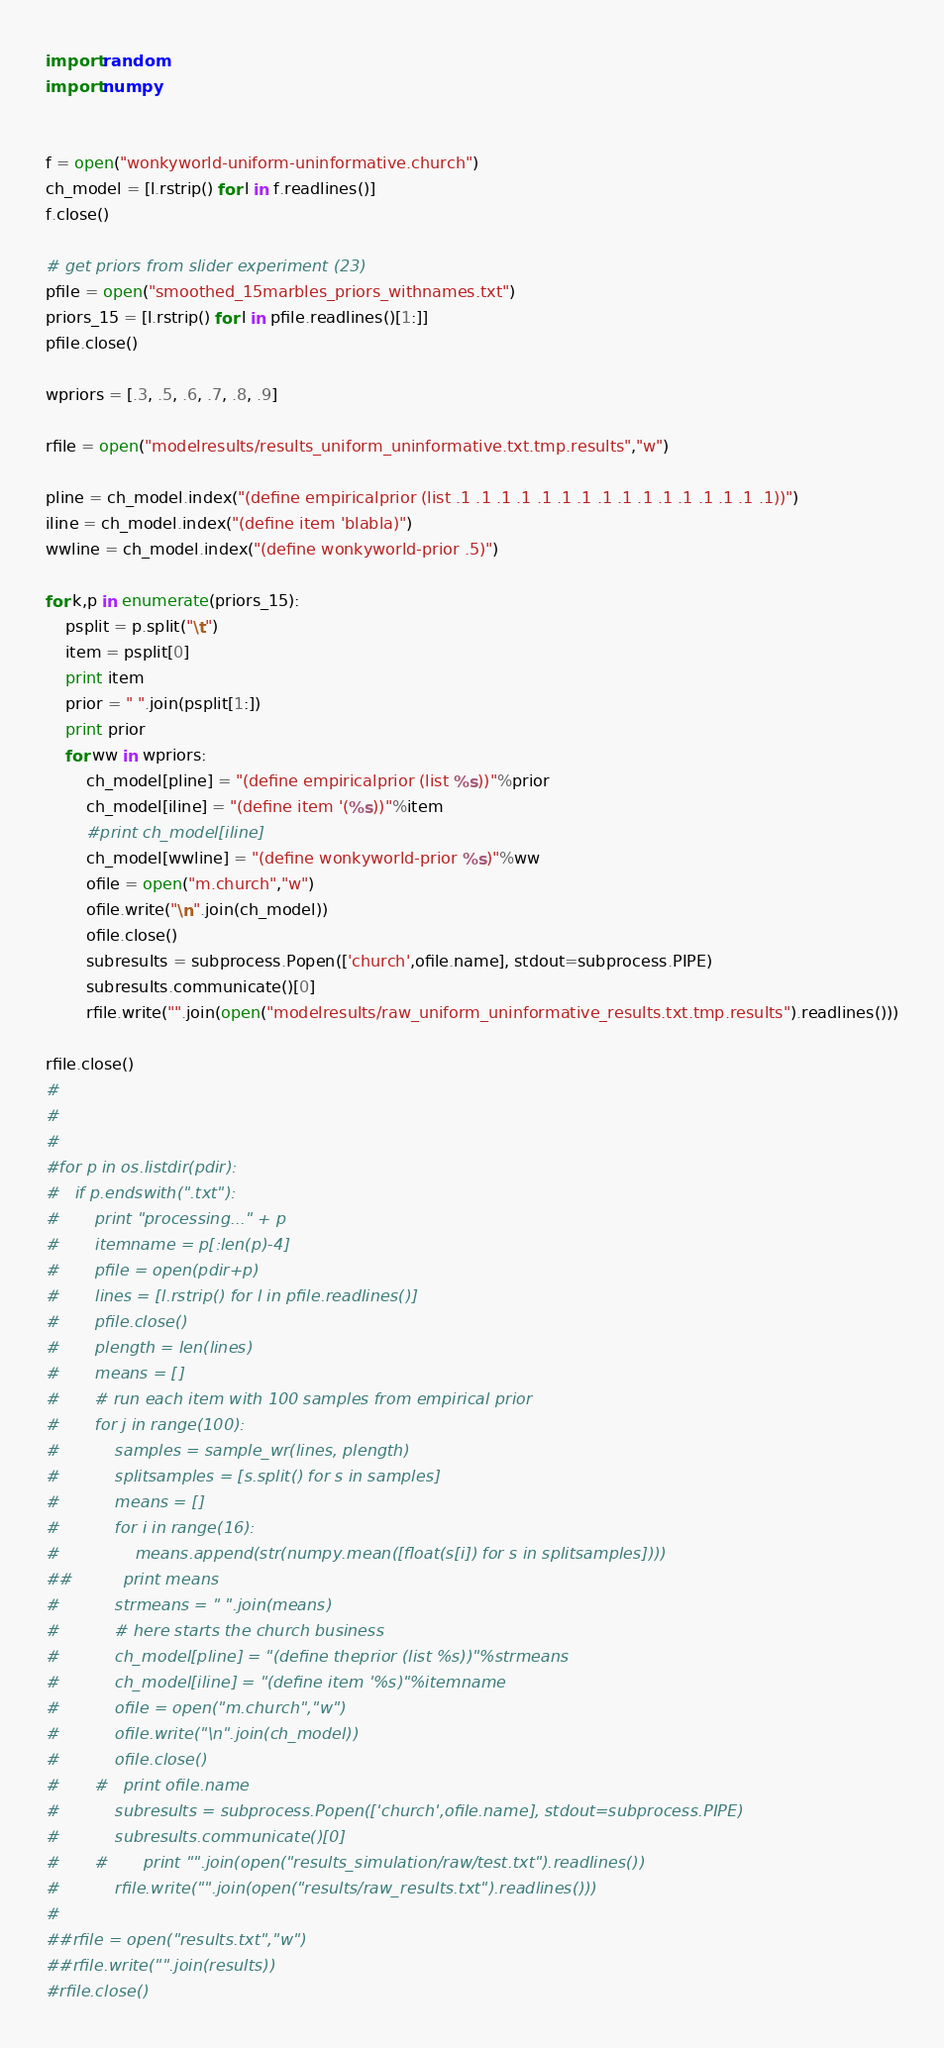<code> <loc_0><loc_0><loc_500><loc_500><_Python_>import random
import numpy


f = open("wonkyworld-uniform-uninformative.church")
ch_model = [l.rstrip() for l in f.readlines()]
f.close()

# get priors from slider experiment (23)
pfile = open("smoothed_15marbles_priors_withnames.txt")
priors_15 = [l.rstrip() for l in pfile.readlines()[1:]]
pfile.close()

wpriors = [.3, .5, .6, .7, .8, .9]

rfile = open("modelresults/results_uniform_uninformative.txt.tmp.results","w")
	
pline = ch_model.index("(define empiricalprior (list .1 .1 .1 .1 .1 .1 .1 .1 .1 .1 .1 .1 .1 .1 .1 .1))")
iline = ch_model.index("(define item 'blabla)")
wwline = ch_model.index("(define wonkyworld-prior .5)")

for k,p in enumerate(priors_15):
	psplit = p.split("\t")
	item = psplit[0]
	print item
	prior = " ".join(psplit[1:])
	print prior
	for ww in wpriors:
		ch_model[pline] = "(define empiricalprior (list %s))"%prior
		ch_model[iline] = "(define item '(%s))"%item
		#print ch_model[iline]
		ch_model[wwline] = "(define wonkyworld-prior %s)"%ww
		ofile = open("m.church","w")
		ofile.write("\n".join(ch_model))
		ofile.close()
		subresults = subprocess.Popen(['church',ofile.name], stdout=subprocess.PIPE)
		subresults.communicate()[0]
		rfile.write("".join(open("modelresults/raw_uniform_uninformative_results.txt.tmp.results").readlines()))
  
rfile.close()
#
#
#
#for p in os.listdir(pdir):
#	if p.endswith(".txt"):
#		print "processing..." + p
#		itemname = p[:len(p)-4]
#		pfile = open(pdir+p)
#		lines = [l.rstrip() for l in pfile.readlines()]
#		pfile.close()
#		plength = len(lines)
#		means = []
#		# run each item with 100 samples from empirical prior
#		for j in range(100):
#			samples = sample_wr(lines, plength)
#			splitsamples = [s.split() for s in samples]
#			means = []
#			for i in range(16):
#				means.append(str(numpy.mean([float(s[i]) for s in splitsamples])))
##			print means
#			strmeans = " ".join(means)
#			# here starts the church business
#			ch_model[pline] = "(define theprior (list %s))"%strmeans
#			ch_model[iline] = "(define item '%s)"%itemname
#			ofile = open("m.church","w")
#			ofile.write("\n".join(ch_model))
#			ofile.close()
#		#	print ofile.name
#			subresults = subprocess.Popen(['church',ofile.name], stdout=subprocess.PIPE)
#			subresults.communicate()[0]
#		#		print "".join(open("results_simulation/raw/test.txt").readlines())
#			rfile.write("".join(open("results/raw_results.txt").readlines()))
#	
##rfile = open("results.txt","w")	
##rfile.write("".join(results))
#rfile.close()
</code> 